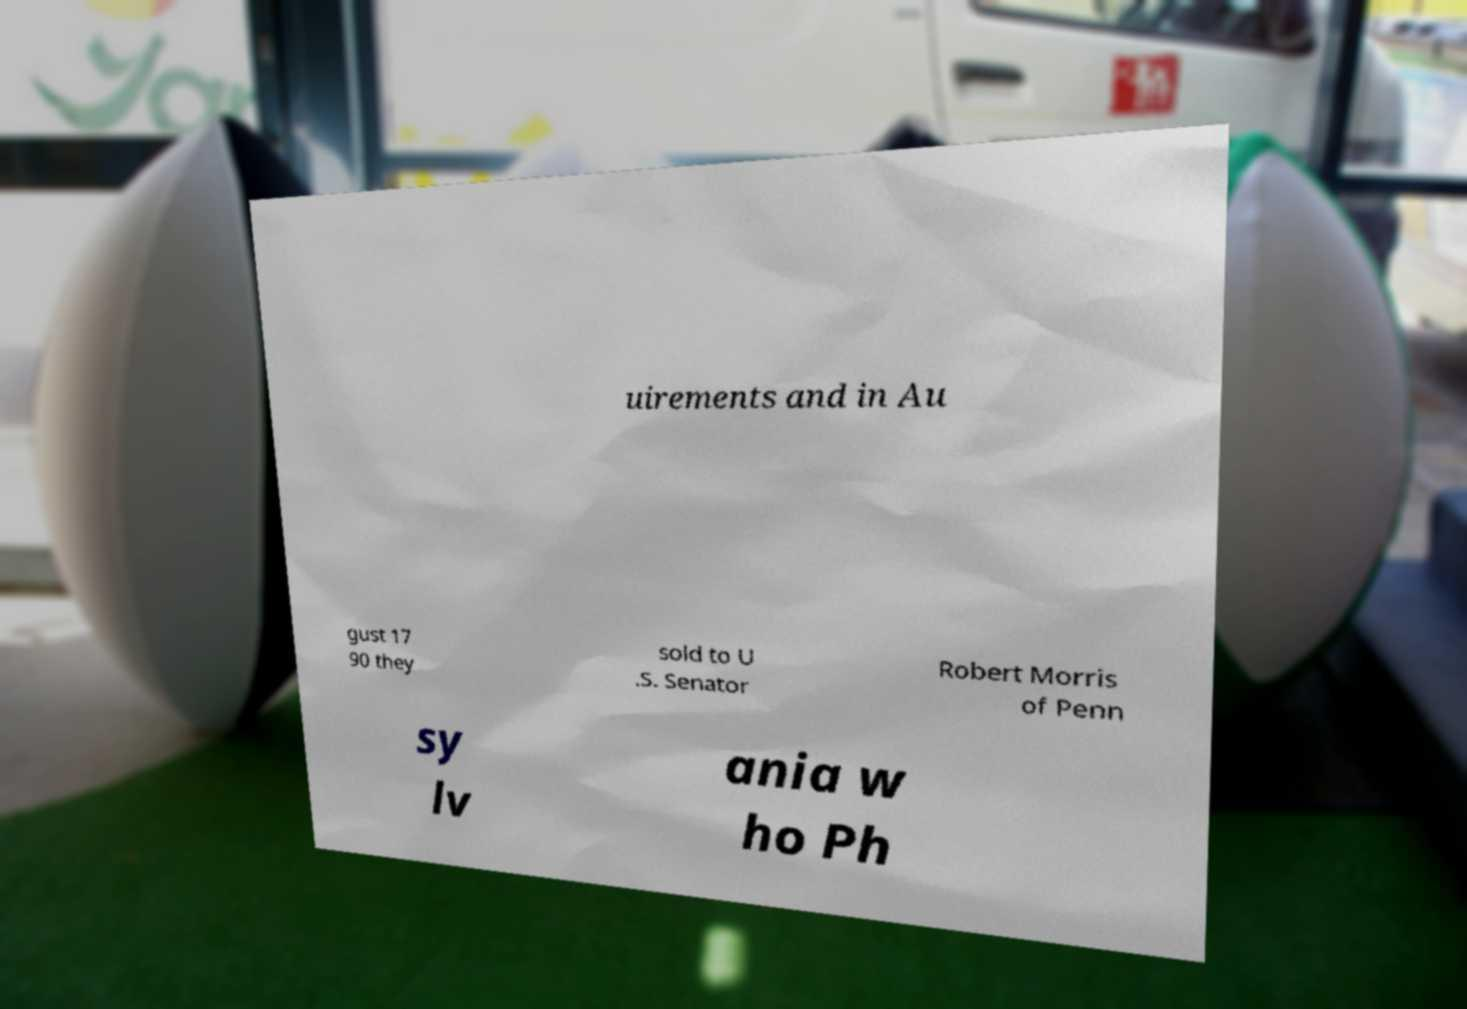What messages or text are displayed in this image? I need them in a readable, typed format. uirements and in Au gust 17 90 they sold to U .S. Senator Robert Morris of Penn sy lv ania w ho Ph 